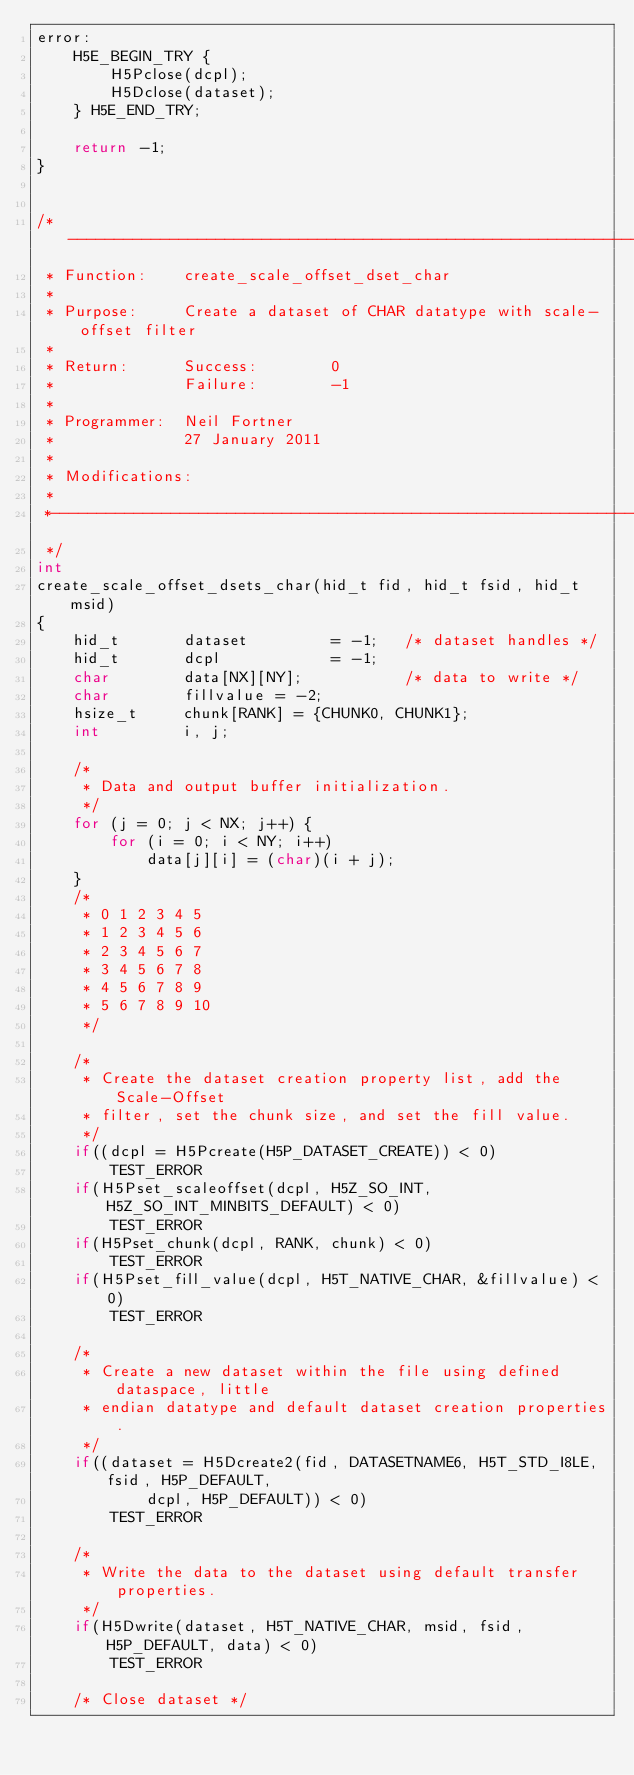Convert code to text. <code><loc_0><loc_0><loc_500><loc_500><_C_>error:
    H5E_BEGIN_TRY {
        H5Pclose(dcpl);
        H5Dclose(dataset);
    } H5E_END_TRY;

    return -1;
}


/*-------------------------------------------------------------------------
 * Function:    create_scale_offset_dset_char
 *
 * Purpose:     Create a dataset of CHAR datatype with scale-offset filter
 *
 * Return:      Success:        0
 *              Failure:        -1
 *
 * Programmer:  Neil Fortner
 *              27 January 2011
 *
 * Modifications:
 *
 *-------------------------------------------------------------------------
 */
int
create_scale_offset_dsets_char(hid_t fid, hid_t fsid, hid_t msid)
{
    hid_t       dataset         = -1;   /* dataset handles */
    hid_t       dcpl            = -1;
    char        data[NX][NY];           /* data to write */
    char        fillvalue = -2;
    hsize_t     chunk[RANK] = {CHUNK0, CHUNK1};
    int         i, j;

    /*
     * Data and output buffer initialization.
     */
    for (j = 0; j < NX; j++) {
        for (i = 0; i < NY; i++)
            data[j][i] = (char)(i + j);
    }
    /*
     * 0 1 2 3 4 5
     * 1 2 3 4 5 6
     * 2 3 4 5 6 7
     * 3 4 5 6 7 8
     * 4 5 6 7 8 9
     * 5 6 7 8 9 10
     */

    /*
     * Create the dataset creation property list, add the Scale-Offset
     * filter, set the chunk size, and set the fill value.
     */
    if((dcpl = H5Pcreate(H5P_DATASET_CREATE)) < 0)
        TEST_ERROR
    if(H5Pset_scaleoffset(dcpl, H5Z_SO_INT, H5Z_SO_INT_MINBITS_DEFAULT) < 0)
        TEST_ERROR
    if(H5Pset_chunk(dcpl, RANK, chunk) < 0)
        TEST_ERROR
    if(H5Pset_fill_value(dcpl, H5T_NATIVE_CHAR, &fillvalue) < 0)
        TEST_ERROR

    /*
     * Create a new dataset within the file using defined dataspace, little
     * endian datatype and default dataset creation properties.
     */
    if((dataset = H5Dcreate2(fid, DATASETNAME6, H5T_STD_I8LE, fsid, H5P_DEFAULT,
            dcpl, H5P_DEFAULT)) < 0)
        TEST_ERROR

    /*
     * Write the data to the dataset using default transfer properties.
     */
    if(H5Dwrite(dataset, H5T_NATIVE_CHAR, msid, fsid, H5P_DEFAULT, data) < 0)
        TEST_ERROR

    /* Close dataset */</code> 